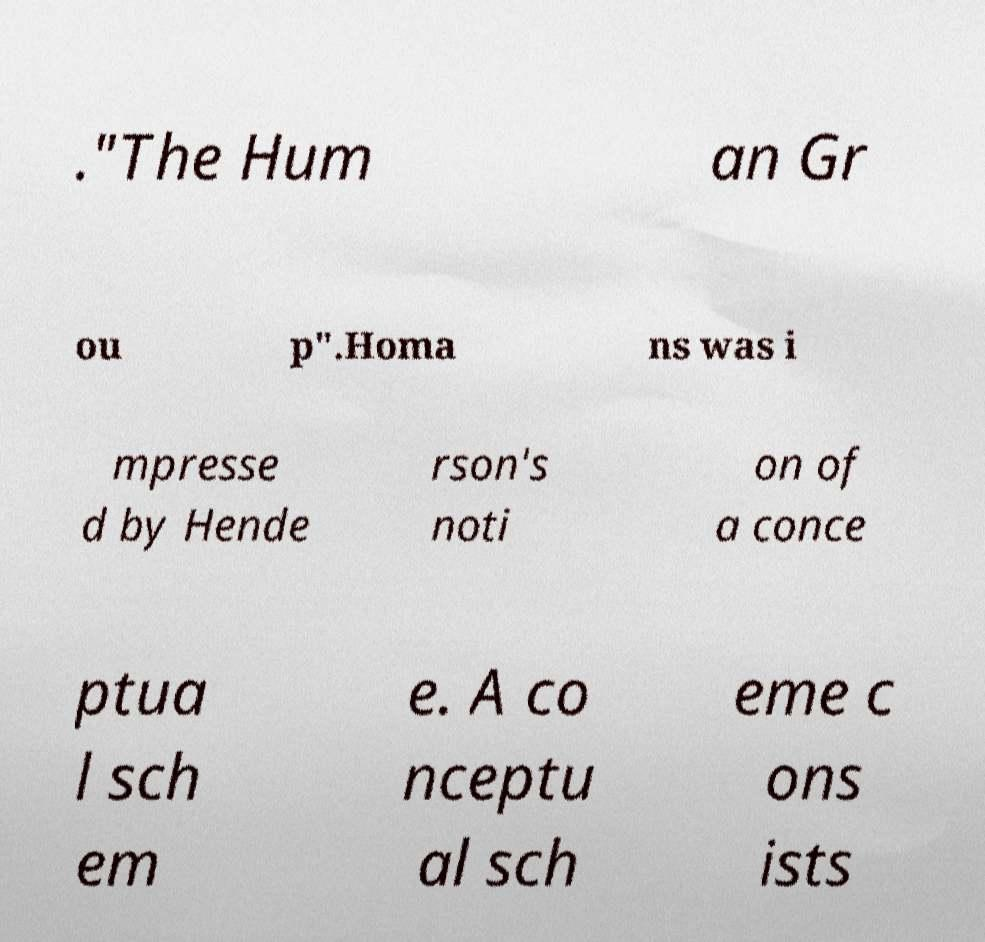Please identify and transcribe the text found in this image. ."The Hum an Gr ou p".Homa ns was i mpresse d by Hende rson's noti on of a conce ptua l sch em e. A co nceptu al sch eme c ons ists 